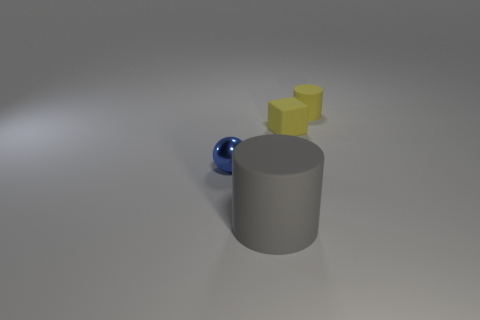Subtract all yellow cylinders. How many cylinders are left? 1 Subtract 2 cylinders. How many cylinders are left? 0 Add 4 tiny spheres. How many objects exist? 8 Add 2 large rubber objects. How many large rubber objects exist? 3 Subtract 0 purple balls. How many objects are left? 4 Subtract all spheres. How many objects are left? 3 Subtract all cyan cylinders. Subtract all blue spheres. How many cylinders are left? 2 Subtract all red blocks. How many red cylinders are left? 0 Subtract all large rubber objects. Subtract all small shiny balls. How many objects are left? 2 Add 3 tiny cylinders. How many tiny cylinders are left? 4 